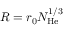<formula> <loc_0><loc_0><loc_500><loc_500>R = r _ { 0 } N _ { H e } ^ { 1 / 3 }</formula> 